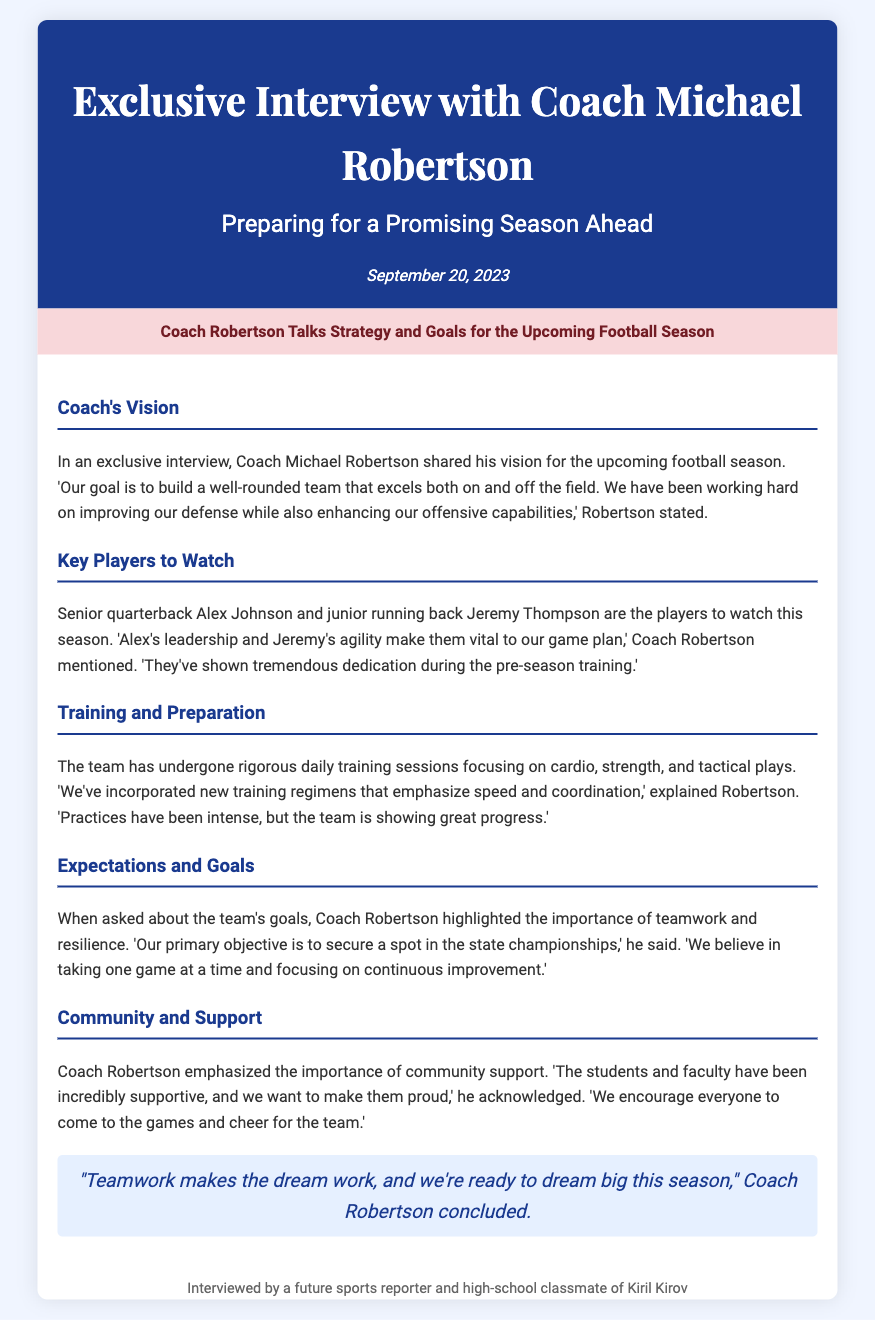what is the name of the coach? The document states that the coach's name is Michael Robertson.
Answer: Michael Robertson when was the interview conducted? The date of the interview is provided in the document as September 20, 2023.
Answer: September 20, 2023 who is the senior quarterback mentioned? The document identifies Alex Johnson as the senior quarterback.
Answer: Alex Johnson what is the primary objective of the team according to Coach Robertson? The primary objective mentioned by Coach Robertson is to secure a spot in the state championships.
Answer: Secure a spot in the state championships which two key players are highlighted in the interview? The interview highlights senior quarterback Alex Johnson and junior running back Jeremy Thompson as key players.
Answer: Alex Johnson and Jeremy Thompson what is emphasized as important for the team in preparation? The document states that teamwork and resilience are important for the team in preparation.
Answer: Teamwork and resilience how does Coach Robertson describe the team's training? Coach Robertson describes the team's training as rigorous with a focus on cardio, strength, and tactical plays.
Answer: Rigorous what quote concludes the interview? The quote that concludes the interview is, "Teamwork makes the dream work, and we're ready to dream big this season."
Answer: "Teamwork makes the dream work, and we're ready to dream big this season." what aspect of community does Coach Robertson emphasize? Coach Robertson emphasizes the importance of community support in achieving the team's goals.
Answer: Community support 